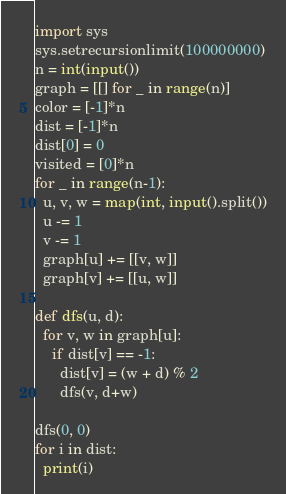Convert code to text. <code><loc_0><loc_0><loc_500><loc_500><_Python_>import sys 
sys.setrecursionlimit(100000000)
n = int(input())
graph = [[] for _ in range(n)]
color = [-1]*n
dist = [-1]*n
dist[0] = 0
visited = [0]*n
for _ in range(n-1):
  u, v, w = map(int, input().split())
  u -= 1
  v -= 1 
  graph[u] += [[v, w]]
  graph[v] += [[u, w]]
  
def dfs(u, d):
  for v, w in graph[u]:
    if dist[v] == -1:
      dist[v] = (w + d) % 2
      dfs(v, d+w)
      
dfs(0, 0)
for i in dist:
  print(i)</code> 